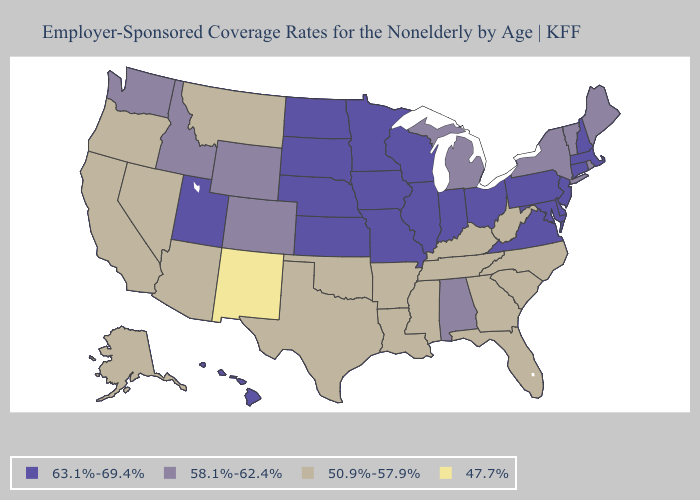What is the value of Tennessee?
Be succinct. 50.9%-57.9%. Does Pennsylvania have the lowest value in the Northeast?
Write a very short answer. No. What is the value of Vermont?
Keep it brief. 58.1%-62.4%. What is the highest value in the USA?
Quick response, please. 63.1%-69.4%. Name the states that have a value in the range 63.1%-69.4%?
Short answer required. Connecticut, Delaware, Hawaii, Illinois, Indiana, Iowa, Kansas, Maryland, Massachusetts, Minnesota, Missouri, Nebraska, New Hampshire, New Jersey, North Dakota, Ohio, Pennsylvania, South Dakota, Utah, Virginia, Wisconsin. Name the states that have a value in the range 58.1%-62.4%?
Concise answer only. Alabama, Colorado, Idaho, Maine, Michigan, New York, Rhode Island, Vermont, Washington, Wyoming. Which states have the lowest value in the USA?
Give a very brief answer. New Mexico. Name the states that have a value in the range 63.1%-69.4%?
Short answer required. Connecticut, Delaware, Hawaii, Illinois, Indiana, Iowa, Kansas, Maryland, Massachusetts, Minnesota, Missouri, Nebraska, New Hampshire, New Jersey, North Dakota, Ohio, Pennsylvania, South Dakota, Utah, Virginia, Wisconsin. Which states have the lowest value in the USA?
Give a very brief answer. New Mexico. Does New Mexico have the lowest value in the West?
Write a very short answer. Yes. Among the states that border Idaho , does Nevada have the highest value?
Write a very short answer. No. Name the states that have a value in the range 50.9%-57.9%?
Give a very brief answer. Alaska, Arizona, Arkansas, California, Florida, Georgia, Kentucky, Louisiana, Mississippi, Montana, Nevada, North Carolina, Oklahoma, Oregon, South Carolina, Tennessee, Texas, West Virginia. Name the states that have a value in the range 50.9%-57.9%?
Concise answer only. Alaska, Arizona, Arkansas, California, Florida, Georgia, Kentucky, Louisiana, Mississippi, Montana, Nevada, North Carolina, Oklahoma, Oregon, South Carolina, Tennessee, Texas, West Virginia. What is the lowest value in the USA?
Answer briefly. 47.7%. Does Rhode Island have a higher value than Nebraska?
Concise answer only. No. 